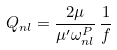<formula> <loc_0><loc_0><loc_500><loc_500>Q _ { n l } = \frac { 2 \mu } { \mu ^ { \prime } \omega _ { n l } ^ { P } } \, \frac { 1 } { f }</formula> 